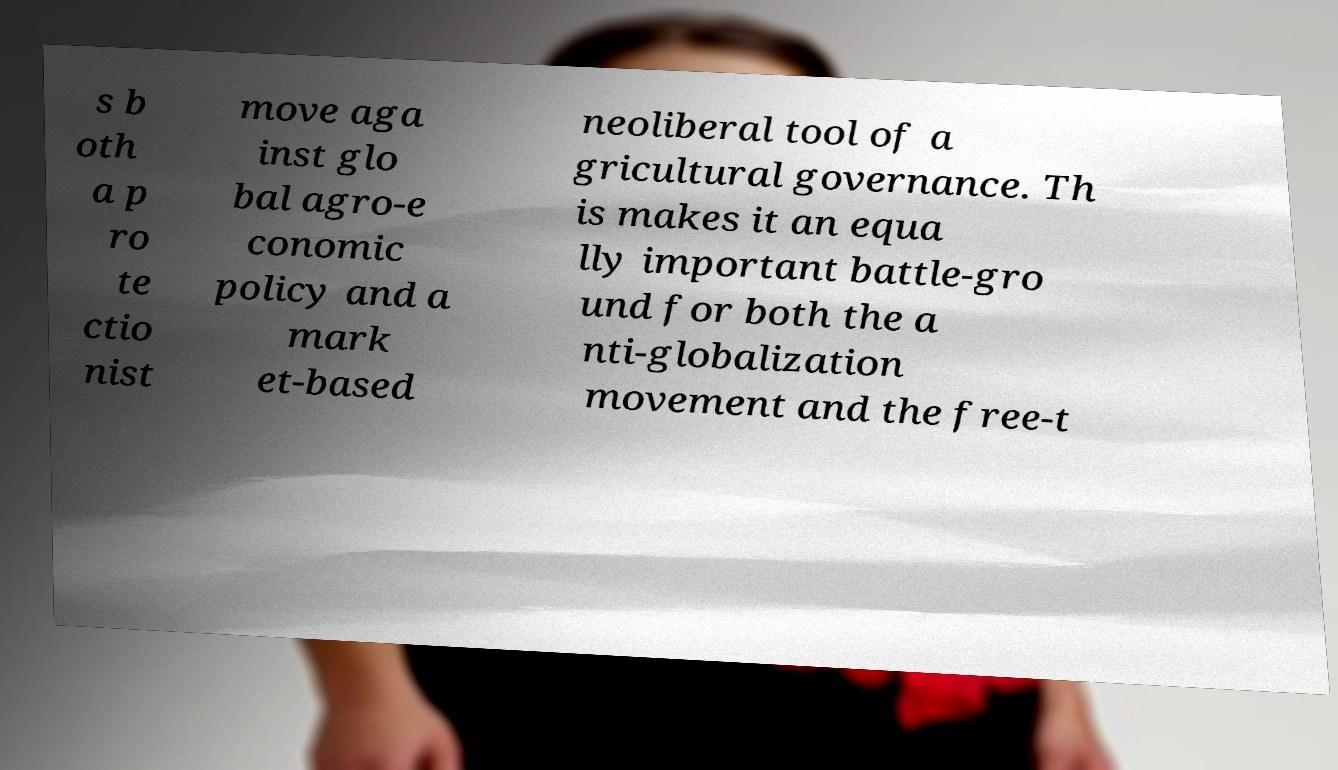For documentation purposes, I need the text within this image transcribed. Could you provide that? s b oth a p ro te ctio nist move aga inst glo bal agro-e conomic policy and a mark et-based neoliberal tool of a gricultural governance. Th is makes it an equa lly important battle-gro und for both the a nti-globalization movement and the free-t 